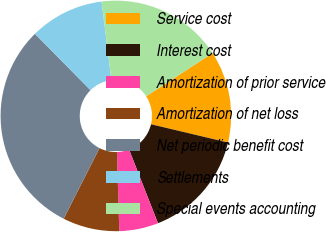<chart> <loc_0><loc_0><loc_500><loc_500><pie_chart><fcel>Service cost<fcel>Interest cost<fcel>Amortization of prior service<fcel>Amortization of net loss<fcel>Net periodic benefit cost<fcel>Settlements<fcel>Special events accounting<nl><fcel>12.88%<fcel>15.34%<fcel>5.48%<fcel>7.95%<fcel>30.14%<fcel>10.41%<fcel>17.81%<nl></chart> 